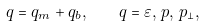Convert formula to latex. <formula><loc_0><loc_0><loc_500><loc_500>q = q _ { m } + q _ { b } , \quad q = \varepsilon , \, p , \, p _ { \perp } ,</formula> 